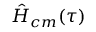<formula> <loc_0><loc_0><loc_500><loc_500>\hat { H } _ { c m } ( \tau )</formula> 